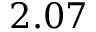<formula> <loc_0><loc_0><loc_500><loc_500>2 . 0 7</formula> 